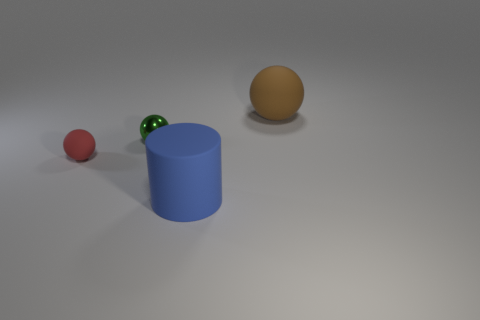How many objects are there in total in the image? There are four objects in total: one small red rubber ball, two small green glass marbles that are close together, one large tan plastic ball, and one blue cylinder. Is there any object in front of the cylinder? Yes, the small red rubber ball and the two green glass marbles are positioned in front of the blue cylinder from the perspective of the viewer. 